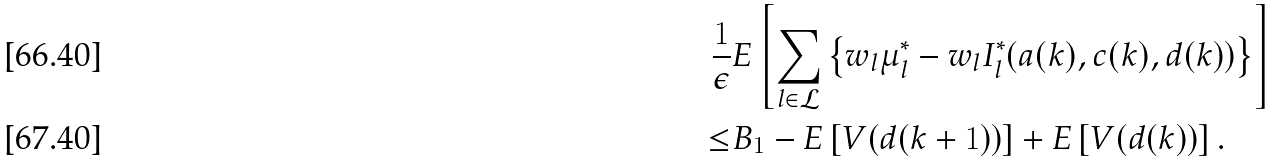Convert formula to latex. <formula><loc_0><loc_0><loc_500><loc_500>\frac { 1 } { \epsilon } & E \left [ \sum _ { l \in \mathcal { L } } \left \{ w _ { l } \mu ^ { * } _ { l } - w _ { l } I _ { l } ^ { * } ( a ( k ) , c ( k ) , d ( k ) ) \right \} \right ] \\ \leq & B _ { 1 } - E \left [ V ( d ( k + 1 ) ) \right ] + E \left [ V ( d ( k ) ) \right ] .</formula> 